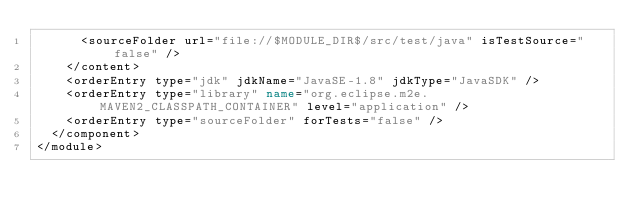Convert code to text. <code><loc_0><loc_0><loc_500><loc_500><_XML_>      <sourceFolder url="file://$MODULE_DIR$/src/test/java" isTestSource="false" />
    </content>
    <orderEntry type="jdk" jdkName="JavaSE-1.8" jdkType="JavaSDK" />
    <orderEntry type="library" name="org.eclipse.m2e.MAVEN2_CLASSPATH_CONTAINER" level="application" />
    <orderEntry type="sourceFolder" forTests="false" />
  </component>
</module></code> 